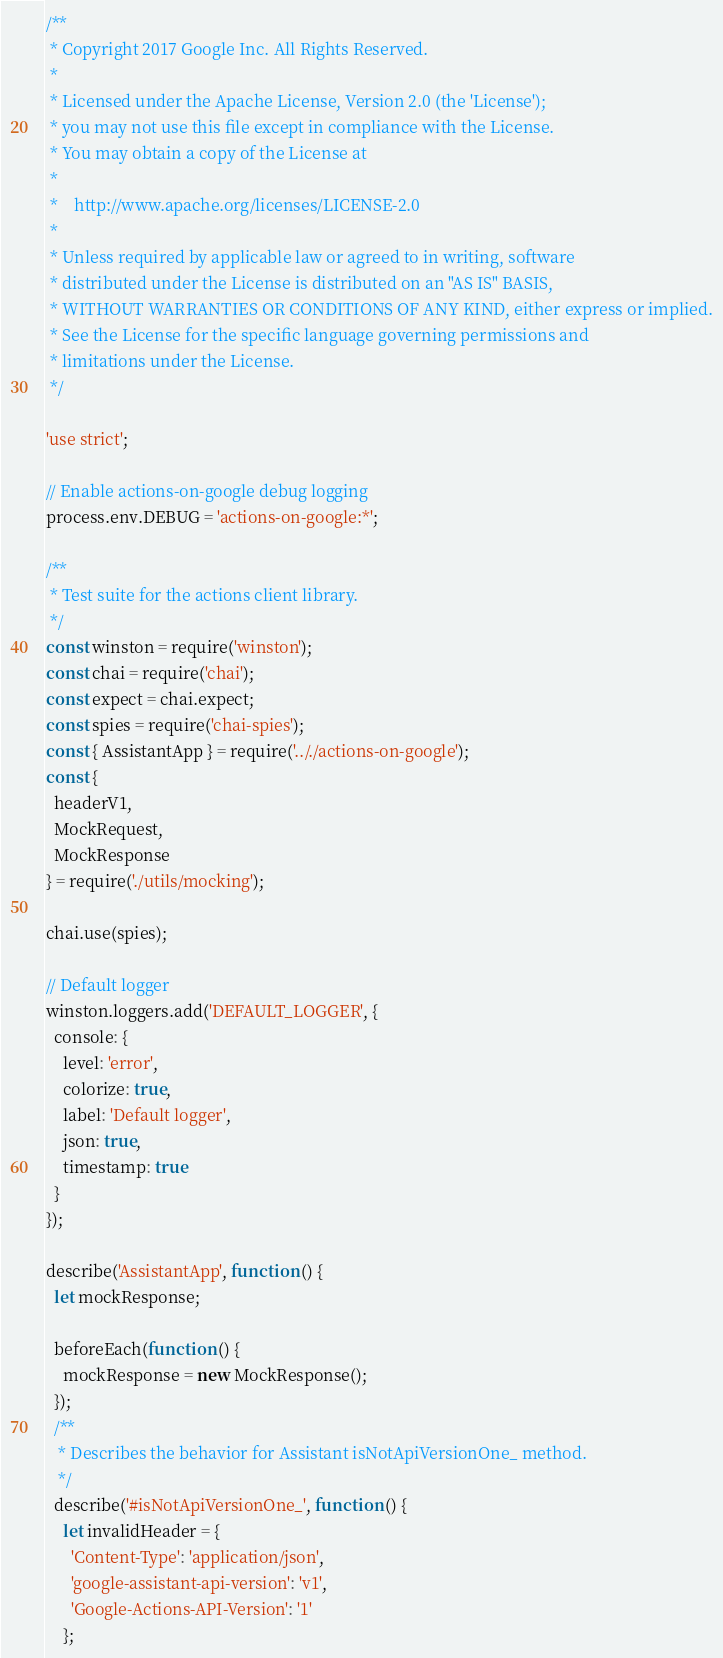Convert code to text. <code><loc_0><loc_0><loc_500><loc_500><_JavaScript_>/**
 * Copyright 2017 Google Inc. All Rights Reserved.
 *
 * Licensed under the Apache License, Version 2.0 (the 'License');
 * you may not use this file except in compliance with the License.
 * You may obtain a copy of the License at
 *
 *    http://www.apache.org/licenses/LICENSE-2.0
 *
 * Unless required by applicable law or agreed to in writing, software
 * distributed under the License is distributed on an "AS IS" BASIS,
 * WITHOUT WARRANTIES OR CONDITIONS OF ANY KIND, either express or implied.
 * See the License for the specific language governing permissions and
 * limitations under the License.
 */

'use strict';

// Enable actions-on-google debug logging
process.env.DEBUG = 'actions-on-google:*';

/**
 * Test suite for the actions client library.
 */
const winston = require('winston');
const chai = require('chai');
const expect = chai.expect;
const spies = require('chai-spies');
const { AssistantApp } = require('.././actions-on-google');
const {
  headerV1,
  MockRequest,
  MockResponse
} = require('./utils/mocking');

chai.use(spies);

// Default logger
winston.loggers.add('DEFAULT_LOGGER', {
  console: {
    level: 'error',
    colorize: true,
    label: 'Default logger',
    json: true,
    timestamp: true
  }
});

describe('AssistantApp', function () {
  let mockResponse;

  beforeEach(function () {
    mockResponse = new MockResponse();
  });
  /**
   * Describes the behavior for Assistant isNotApiVersionOne_ method.
   */
  describe('#isNotApiVersionOne_', function () {
    let invalidHeader = {
      'Content-Type': 'application/json',
      'google-assistant-api-version': 'v1',
      'Google-Actions-API-Version': '1'
    };
</code> 